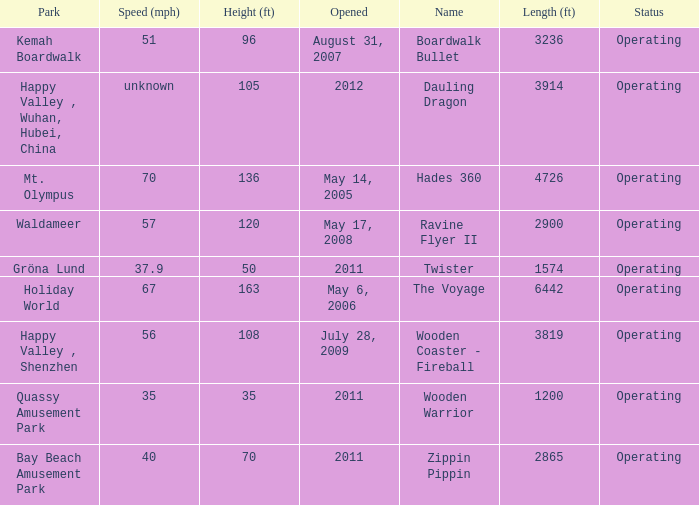Give me the full table as a dictionary. {'header': ['Park', 'Speed (mph)', 'Height (ft)', 'Opened', 'Name', 'Length (ft)', 'Status'], 'rows': [['Kemah Boardwalk', '51', '96', 'August 31, 2007', 'Boardwalk Bullet', '3236', 'Operating'], ['Happy Valley , Wuhan, Hubei, China', 'unknown', '105', '2012', 'Dauling Dragon', '3914', 'Operating'], ['Mt. Olympus', '70', '136', 'May 14, 2005', 'Hades 360', '4726', 'Operating'], ['Waldameer', '57', '120', 'May 17, 2008', 'Ravine Flyer II', '2900', 'Operating'], ['Gröna Lund', '37.9', '50', '2011', 'Twister', '1574', 'Operating'], ['Holiday World', '67', '163', 'May 6, 2006', 'The Voyage', '6442', 'Operating'], ['Happy Valley , Shenzhen', '56', '108', 'July 28, 2009', 'Wooden Coaster - Fireball', '3819', 'Operating'], ['Quassy Amusement Park', '35', '35', '2011', 'Wooden Warrior', '1200', 'Operating'], ['Bay Beach Amusement Park', '40', '70', '2011', 'Zippin Pippin', '2865', 'Operating']]} What is the length of the coaster with the unknown speed 3914.0. 